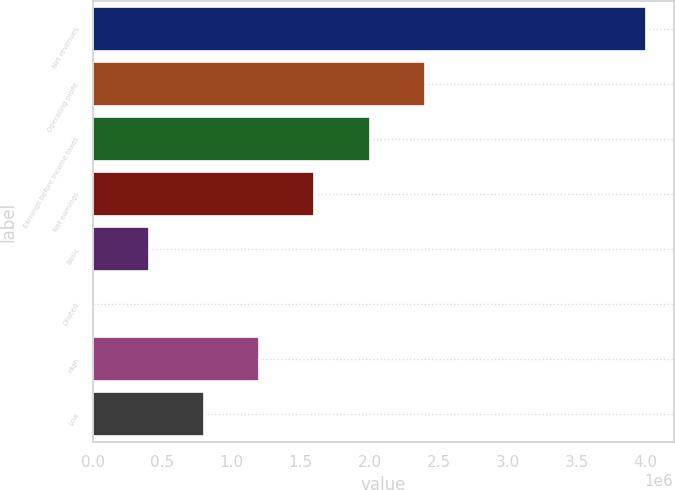<chart> <loc_0><loc_0><loc_500><loc_500><bar_chart><fcel>Net revenues<fcel>Operating profit<fcel>Earnings before income taxes<fcel>Net earnings<fcel>Basic<fcel>Diluted<fcel>High<fcel>Low<nl><fcel>4.00216e+06<fcel>2.4013e+06<fcel>2.00108e+06<fcel>1.60087e+06<fcel>400219<fcel>2.74<fcel>1.20065e+06<fcel>800434<nl></chart> 